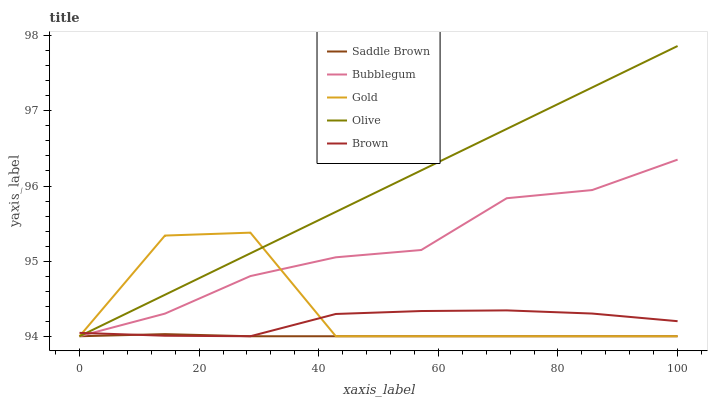Does Saddle Brown have the minimum area under the curve?
Answer yes or no. Yes. Does Olive have the maximum area under the curve?
Answer yes or no. Yes. Does Gold have the minimum area under the curve?
Answer yes or no. No. Does Gold have the maximum area under the curve?
Answer yes or no. No. Is Olive the smoothest?
Answer yes or no. Yes. Is Gold the roughest?
Answer yes or no. Yes. Is Saddle Brown the smoothest?
Answer yes or no. No. Is Saddle Brown the roughest?
Answer yes or no. No. Does Olive have the lowest value?
Answer yes or no. Yes. Does Olive have the highest value?
Answer yes or no. Yes. Does Gold have the highest value?
Answer yes or no. No. Does Saddle Brown intersect Brown?
Answer yes or no. Yes. Is Saddle Brown less than Brown?
Answer yes or no. No. Is Saddle Brown greater than Brown?
Answer yes or no. No. 